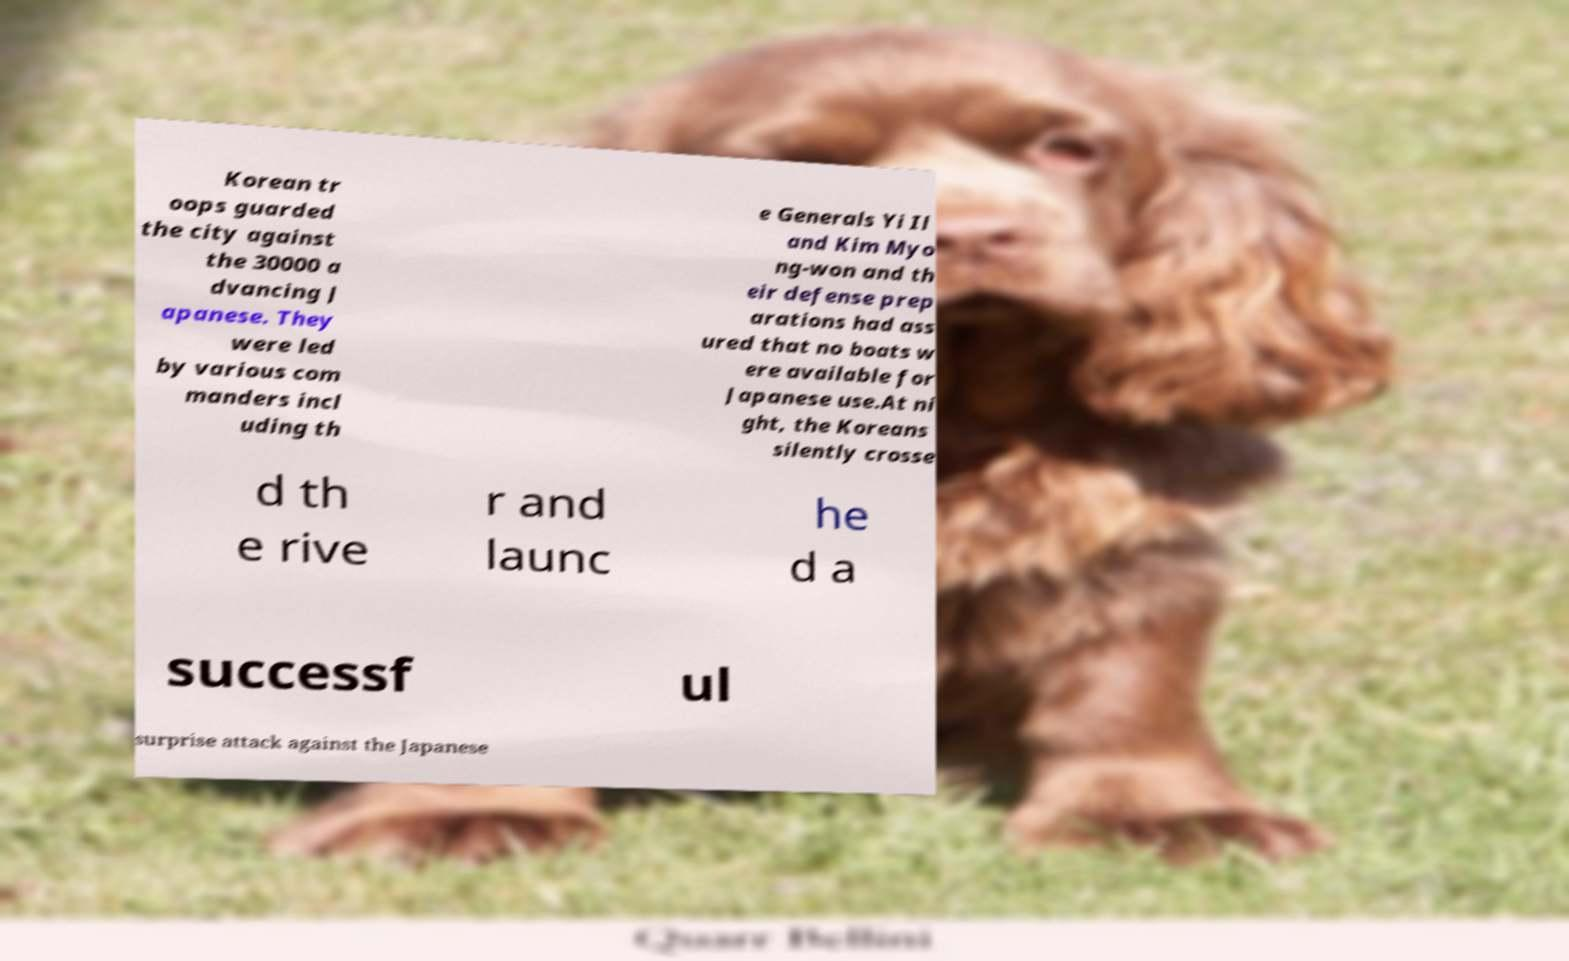Can you accurately transcribe the text from the provided image for me? Korean tr oops guarded the city against the 30000 a dvancing J apanese. They were led by various com manders incl uding th e Generals Yi Il and Kim Myo ng-won and th eir defense prep arations had ass ured that no boats w ere available for Japanese use.At ni ght, the Koreans silently crosse d th e rive r and launc he d a successf ul surprise attack against the Japanese 